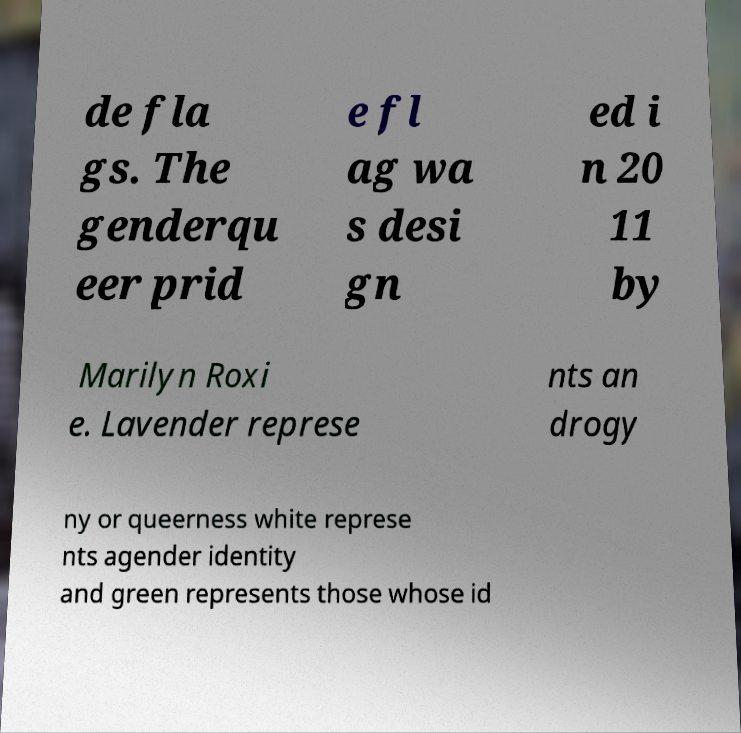For documentation purposes, I need the text within this image transcribed. Could you provide that? de fla gs. The genderqu eer prid e fl ag wa s desi gn ed i n 20 11 by Marilyn Roxi e. Lavender represe nts an drogy ny or queerness white represe nts agender identity and green represents those whose id 